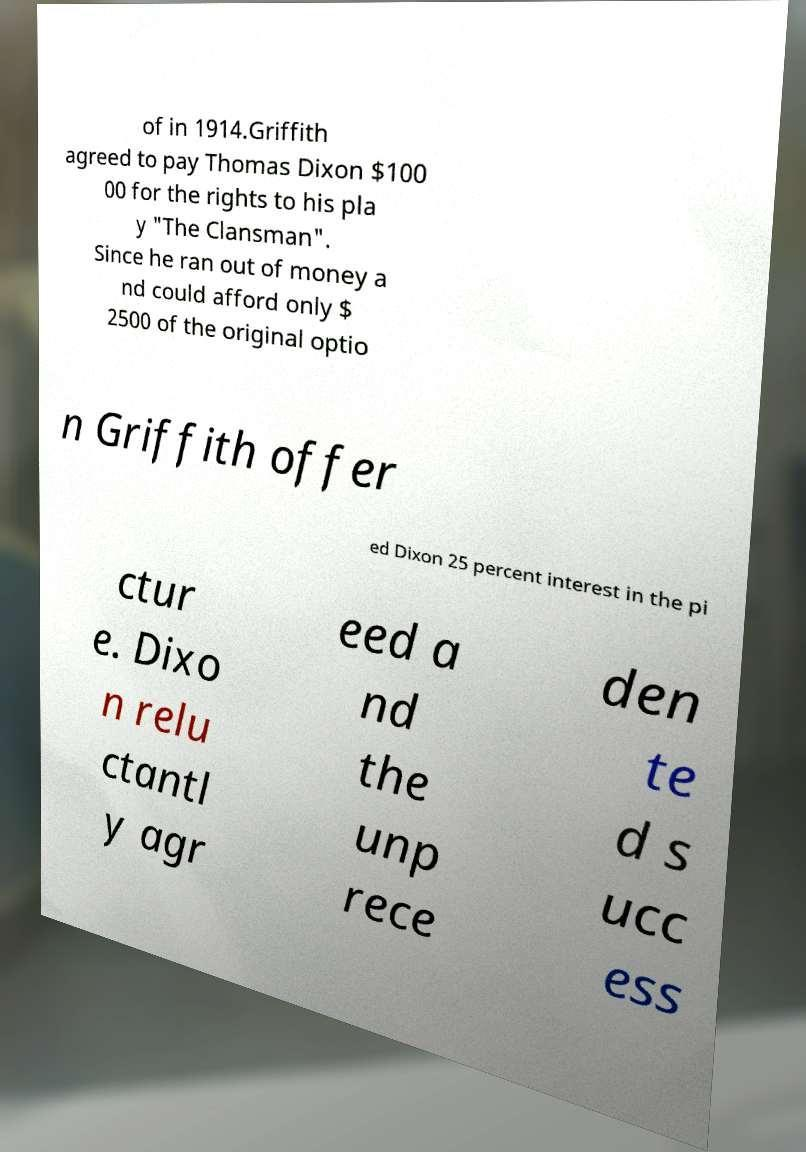Could you assist in decoding the text presented in this image and type it out clearly? of in 1914.Griffith agreed to pay Thomas Dixon $100 00 for the rights to his pla y "The Clansman". Since he ran out of money a nd could afford only $ 2500 of the original optio n Griffith offer ed Dixon 25 percent interest in the pi ctur e. Dixo n relu ctantl y agr eed a nd the unp rece den te d s ucc ess 